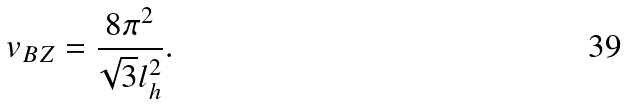<formula> <loc_0><loc_0><loc_500><loc_500>v _ { B Z } = \frac { 8 \pi ^ { 2 } } { \sqrt { 3 } l _ { h } ^ { 2 } } .</formula> 